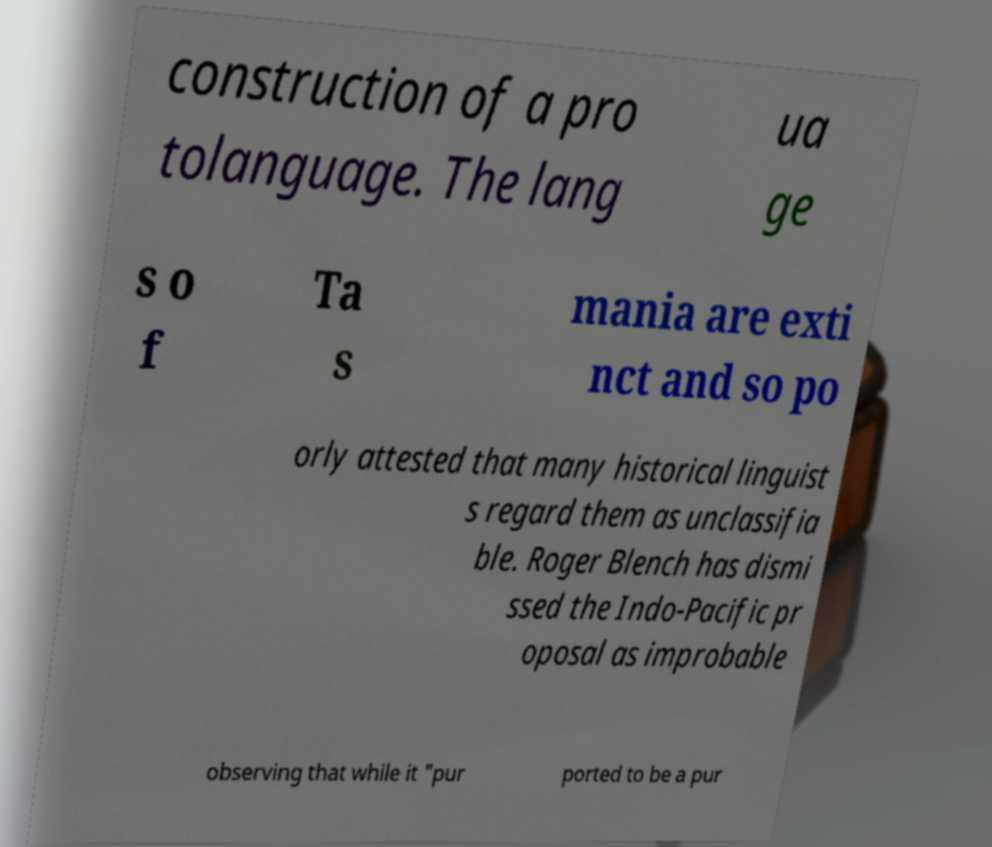For documentation purposes, I need the text within this image transcribed. Could you provide that? construction of a pro tolanguage. The lang ua ge s o f Ta s mania are exti nct and so po orly attested that many historical linguist s regard them as unclassifia ble. Roger Blench has dismi ssed the Indo-Pacific pr oposal as improbable observing that while it "pur ported to be a pur 